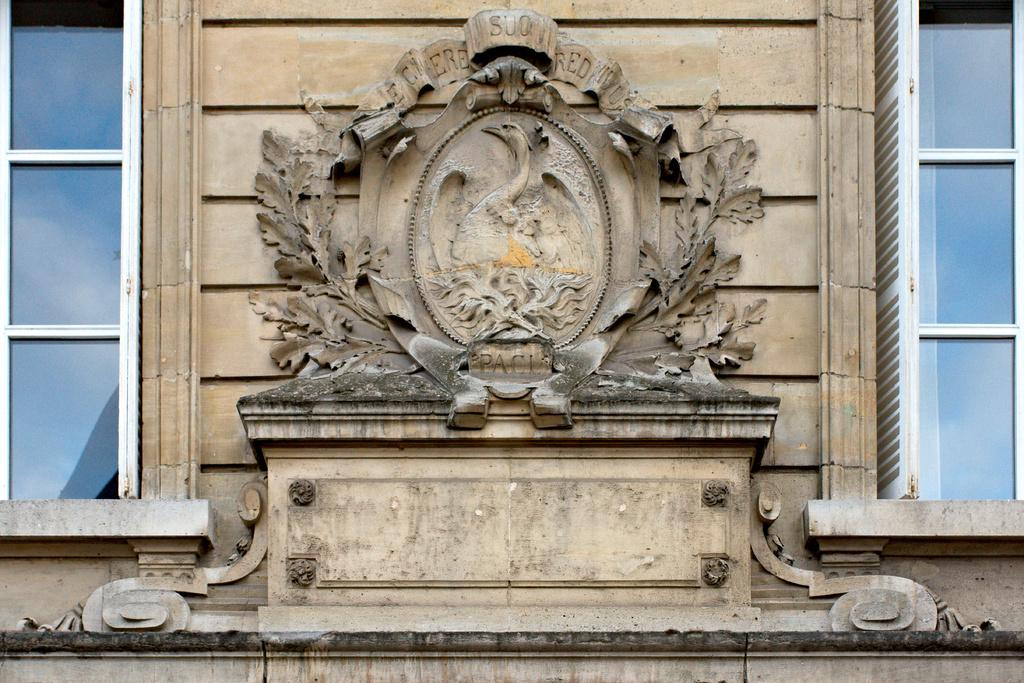What is present on the wall in the image? The wall has sculptures on it and text. How many glass windows are visible in the image? There are two glass windows in the image, one on each corner. What type of canvas is hanging on the wall in the image? There is no canvas present in the image; the wall features sculptures and text. 